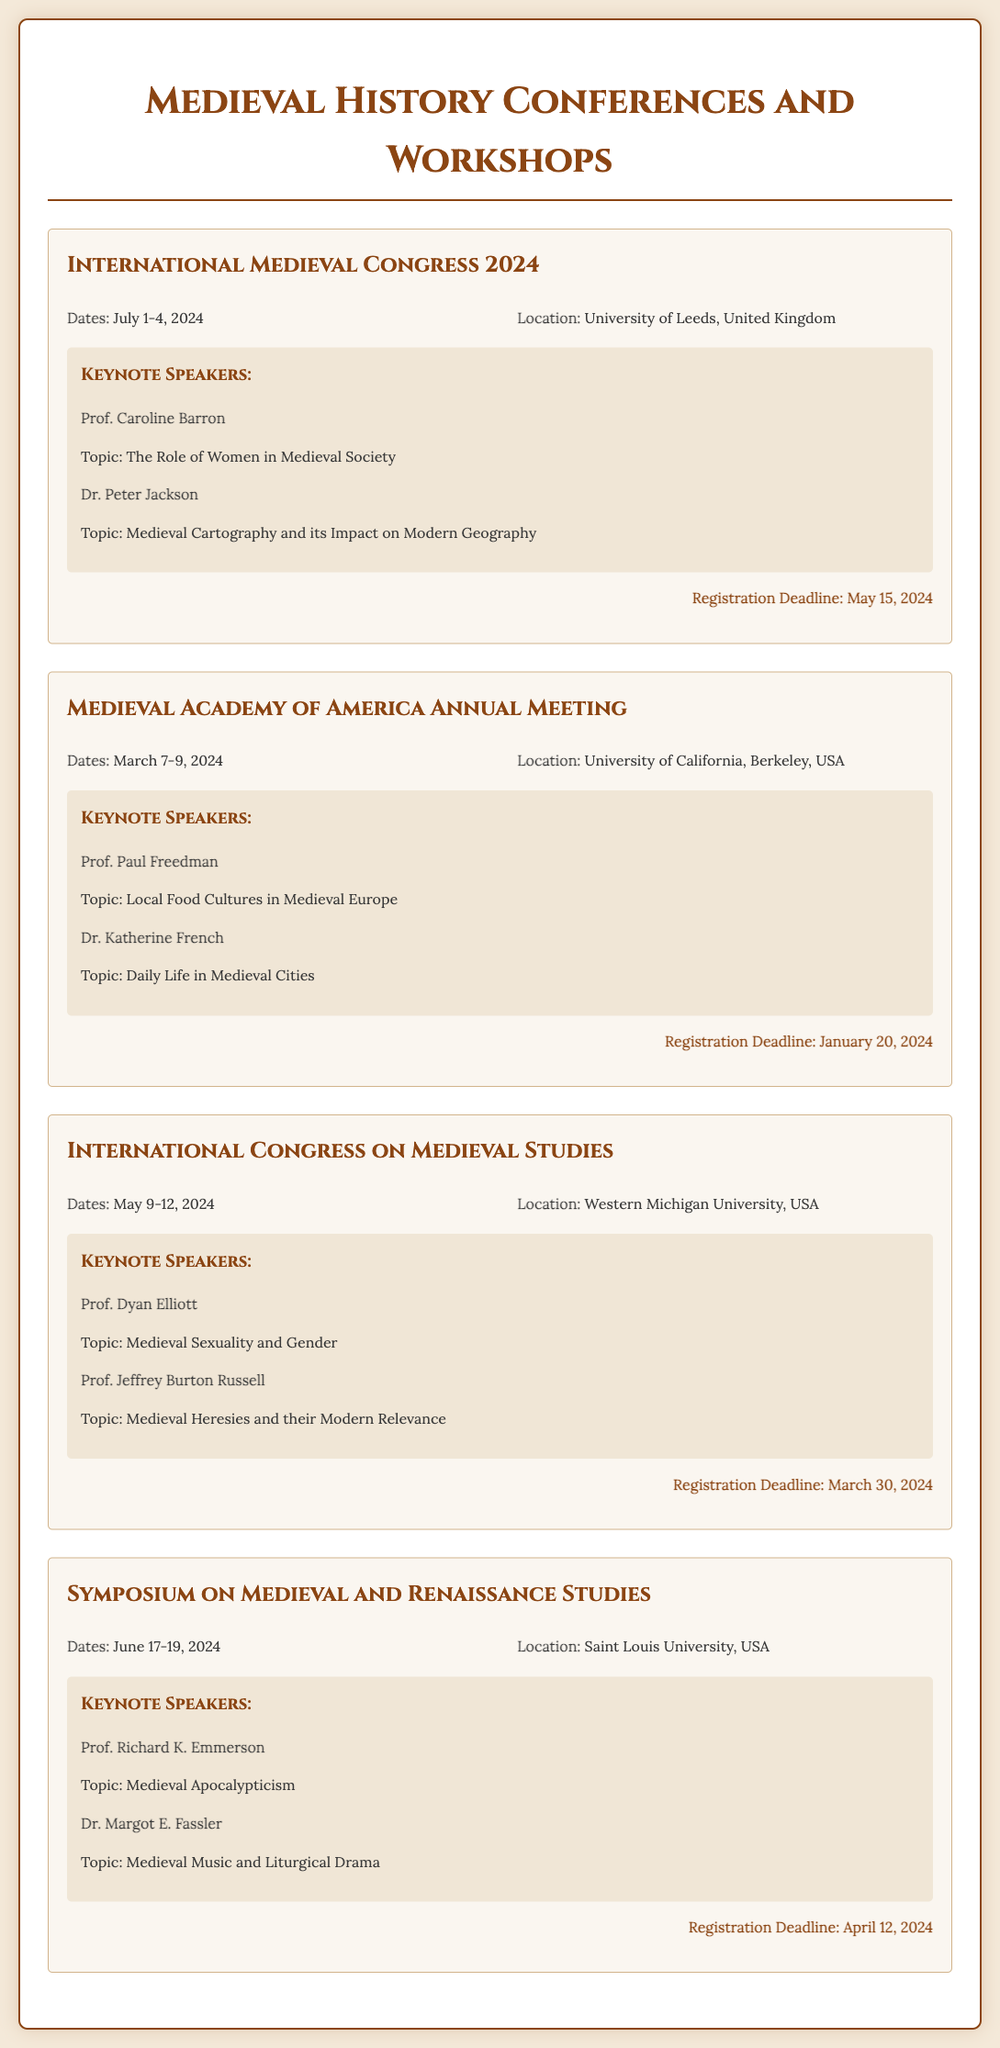what are the dates for the International Medieval Congress 2024? The dates for the International Medieval Congress 2024 are specified clearly in the document.
Answer: July 1-4, 2024 who is a keynote speaker for the Medieval Academy of America Annual Meeting? The document lists the keynote speakers for the Medieval Academy of America Annual Meeting.
Answer: Prof. Paul Freedman what is the location of the International Congress on Medieval Studies? The document provides the location for the International Congress on Medieval Studies.
Answer: Western Michigan University, USA what is the registration deadline for the Symposium on Medieval and Renaissance Studies? The registration deadline is mentioned in the document for the Symposium on Medieval and Renaissance Studies.
Answer: April 12, 2024 how many days does the Medieval Academy of America Annual Meeting last? The duration of the Medieval Academy of America Annual Meeting is indicated in the date range.
Answer: 3 days what topic does Dr. Peter Jackson discuss at the International Medieval Congress 2024? Dr. Peter Jackson's topic is explicitly stated in connection with his participation in the conference.
Answer: Medieval Cartography and its Impact on Modern Geography which event occurs first in 2024? To answer this, one must consider the date ranges for all events listed in the document.
Answer: Medieval Academy of America Annual Meeting who are the speakers at the International Congress on Medieval Studies? The document lists two keynote speakers for the event, providing their names and topics.
Answer: Prof. Dyan Elliott, Prof. Jeffrey Burton Russell 